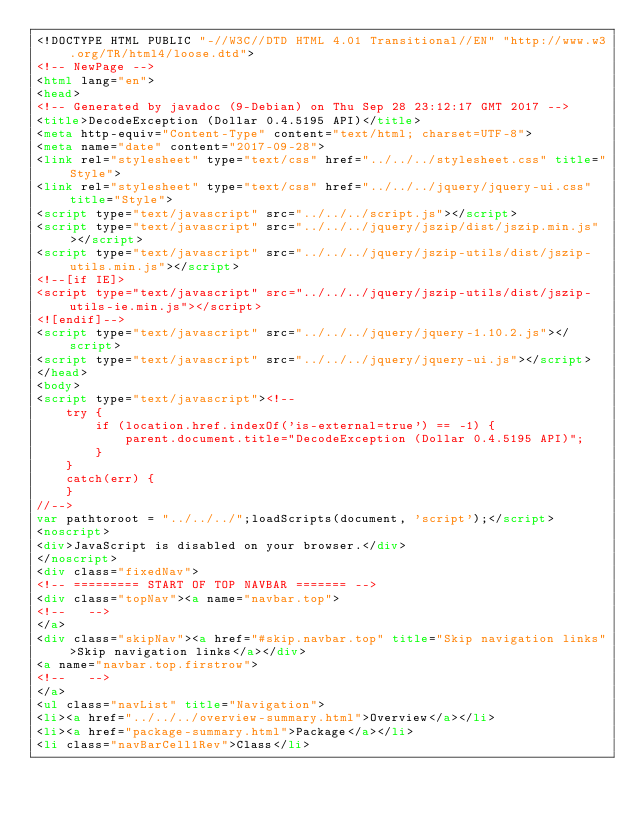Convert code to text. <code><loc_0><loc_0><loc_500><loc_500><_HTML_><!DOCTYPE HTML PUBLIC "-//W3C//DTD HTML 4.01 Transitional//EN" "http://www.w3.org/TR/html4/loose.dtd">
<!-- NewPage -->
<html lang="en">
<head>
<!-- Generated by javadoc (9-Debian) on Thu Sep 28 23:12:17 GMT 2017 -->
<title>DecodeException (Dollar 0.4.5195 API)</title>
<meta http-equiv="Content-Type" content="text/html; charset=UTF-8">
<meta name="date" content="2017-09-28">
<link rel="stylesheet" type="text/css" href="../../../stylesheet.css" title="Style">
<link rel="stylesheet" type="text/css" href="../../../jquery/jquery-ui.css" title="Style">
<script type="text/javascript" src="../../../script.js"></script>
<script type="text/javascript" src="../../../jquery/jszip/dist/jszip.min.js"></script>
<script type="text/javascript" src="../../../jquery/jszip-utils/dist/jszip-utils.min.js"></script>
<!--[if IE]>
<script type="text/javascript" src="../../../jquery/jszip-utils/dist/jszip-utils-ie.min.js"></script>
<![endif]-->
<script type="text/javascript" src="../../../jquery/jquery-1.10.2.js"></script>
<script type="text/javascript" src="../../../jquery/jquery-ui.js"></script>
</head>
<body>
<script type="text/javascript"><!--
    try {
        if (location.href.indexOf('is-external=true') == -1) {
            parent.document.title="DecodeException (Dollar 0.4.5195 API)";
        }
    }
    catch(err) {
    }
//-->
var pathtoroot = "../../../";loadScripts(document, 'script');</script>
<noscript>
<div>JavaScript is disabled on your browser.</div>
</noscript>
<div class="fixedNav">
<!-- ========= START OF TOP NAVBAR ======= -->
<div class="topNav"><a name="navbar.top">
<!--   -->
</a>
<div class="skipNav"><a href="#skip.navbar.top" title="Skip navigation links">Skip navigation links</a></div>
<a name="navbar.top.firstrow">
<!--   -->
</a>
<ul class="navList" title="Navigation">
<li><a href="../../../overview-summary.html">Overview</a></li>
<li><a href="package-summary.html">Package</a></li>
<li class="navBarCell1Rev">Class</li></code> 